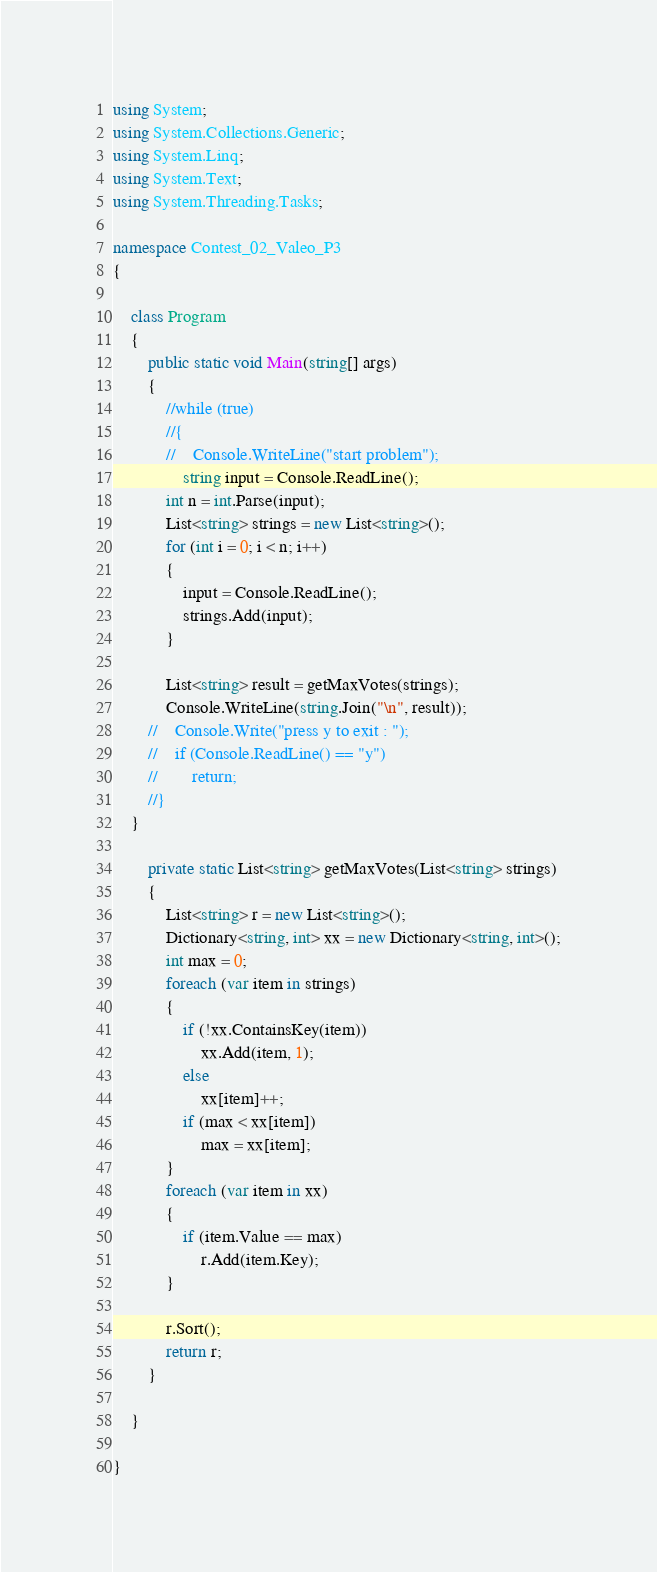<code> <loc_0><loc_0><loc_500><loc_500><_C#_>using System;
using System.Collections.Generic;
using System.Linq;
using System.Text;
using System.Threading.Tasks;

namespace Contest_02_Valeo_P3
{

    class Program
    {
        public static void Main(string[] args)
        {
            //while (true)
            //{
            //    Console.WriteLine("start problem");
                string input = Console.ReadLine();
            int n = int.Parse(input);
            List<string> strings = new List<string>();
            for (int i = 0; i < n; i++)
            {
                input = Console.ReadLine();
                strings.Add(input);
            }

            List<string> result = getMaxVotes(strings);
            Console.WriteLine(string.Join("\n", result));
        //    Console.Write("press y to exit : ");
        //    if (Console.ReadLine() == "y")
        //        return;
        //}
    }

        private static List<string> getMaxVotes(List<string> strings)
        {
            List<string> r = new List<string>();
            Dictionary<string, int> xx = new Dictionary<string, int>();
            int max = 0;
            foreach (var item in strings)
            {
                if (!xx.ContainsKey(item))
                    xx.Add(item, 1);
                else
                    xx[item]++;
                if (max < xx[item])
                    max = xx[item];
            }
            foreach (var item in xx)
            {
                if (item.Value == max)
                    r.Add(item.Key);
            }

            r.Sort();
            return r;
        }

    }
    
}
</code> 